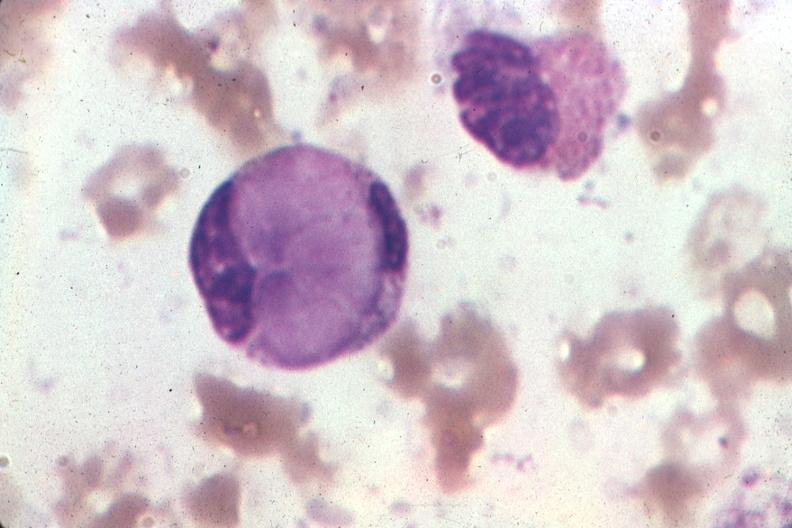s whipples disease present?
Answer the question using a single word or phrase. No 